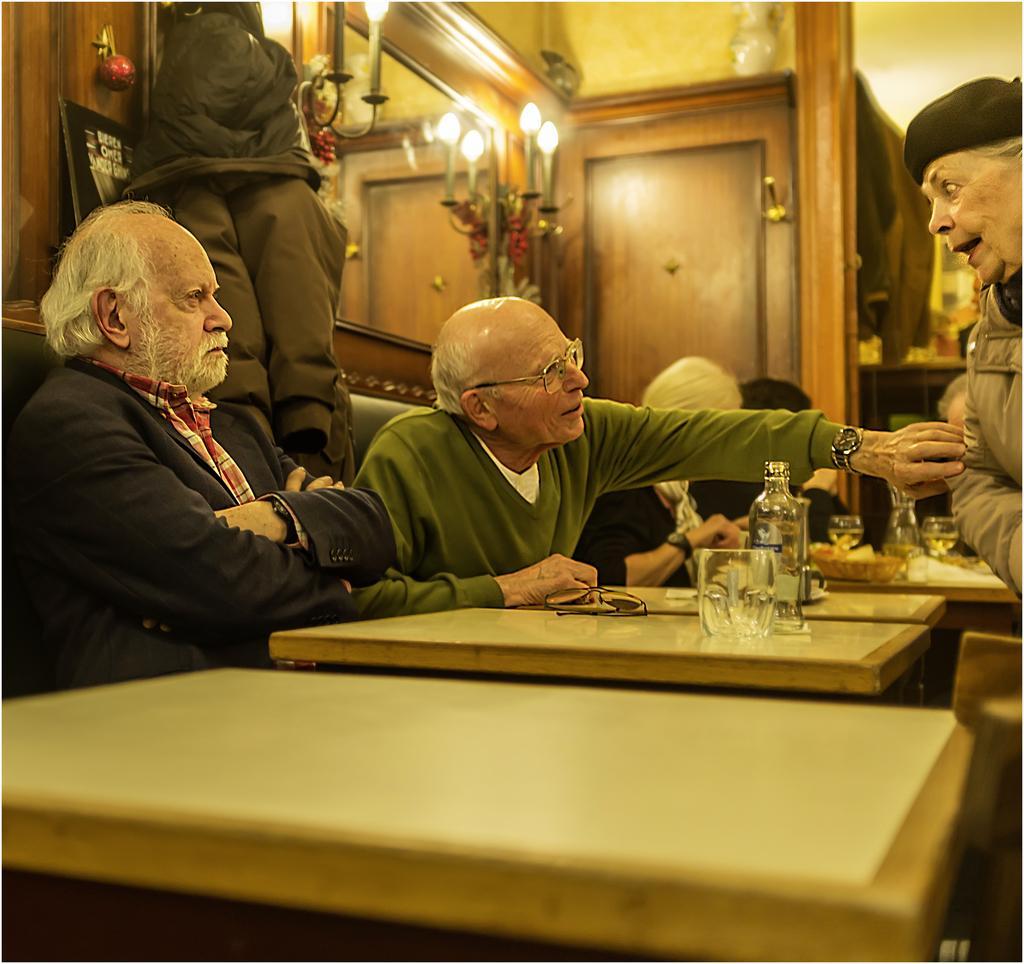How would you summarize this image in a sentence or two? In this we can see two people one in blue jacket and one in green hoodie sitting on the sofa around the table on which there is a bottle, cup and shades and around them there is a mirror, lamp and on the other side there is person standing opposite to them. 